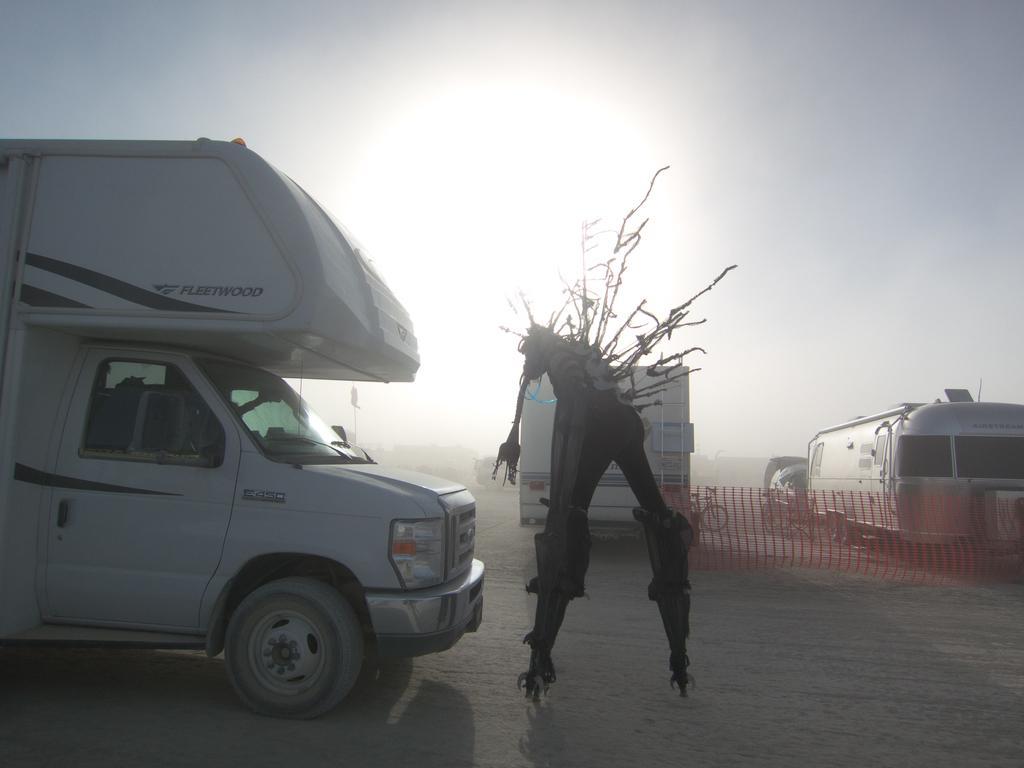Could you give a brief overview of what you see in this image? This picture is clicked outside. In the center we can see some objects and we can see the group of vehicles and some other objects. In the background we can see the sky and we can see some objects in the background. 